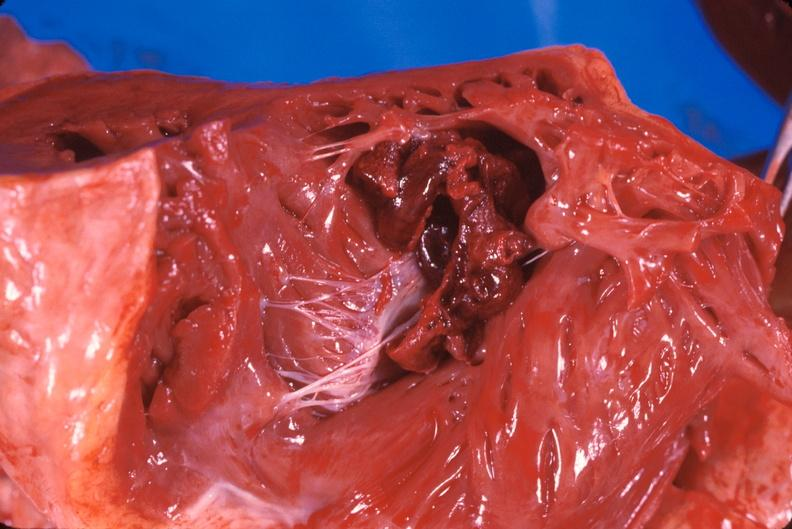where is this?
Answer the question using a single word or phrase. Heart 